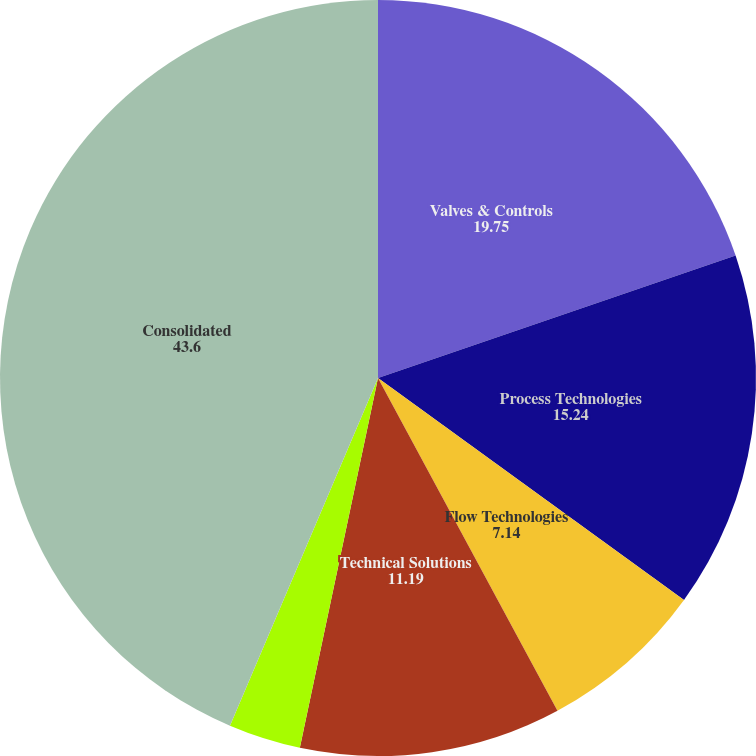Convert chart. <chart><loc_0><loc_0><loc_500><loc_500><pie_chart><fcel>Valves & Controls<fcel>Process Technologies<fcel>Flow Technologies<fcel>Technical Solutions<fcel>Other<fcel>Consolidated<nl><fcel>19.75%<fcel>15.24%<fcel>7.14%<fcel>11.19%<fcel>3.09%<fcel>43.6%<nl></chart> 